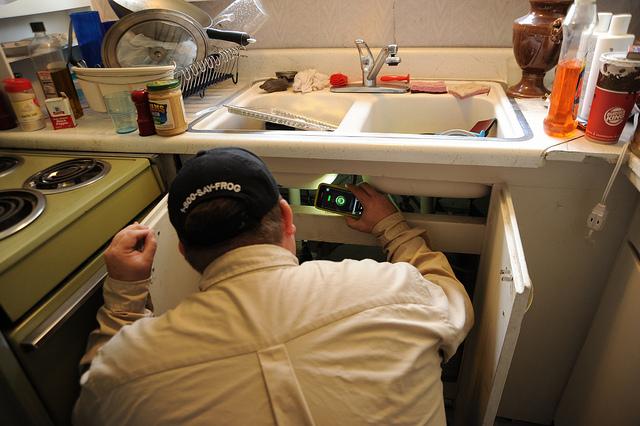What color is the stove?
Write a very short answer. Green. Is the counter messy?
Give a very brief answer. Yes. What is the man looking at?
Write a very short answer. Pipes. 